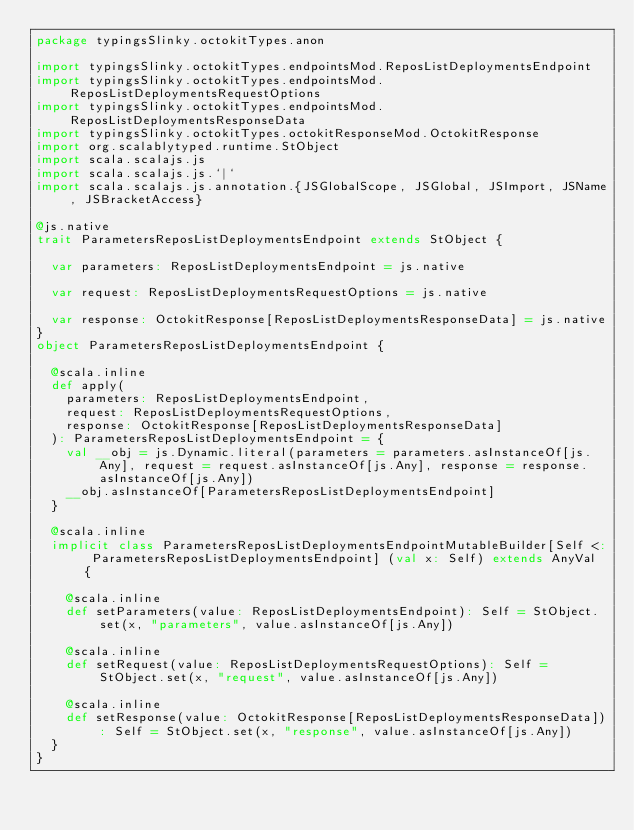Convert code to text. <code><loc_0><loc_0><loc_500><loc_500><_Scala_>package typingsSlinky.octokitTypes.anon

import typingsSlinky.octokitTypes.endpointsMod.ReposListDeploymentsEndpoint
import typingsSlinky.octokitTypes.endpointsMod.ReposListDeploymentsRequestOptions
import typingsSlinky.octokitTypes.endpointsMod.ReposListDeploymentsResponseData
import typingsSlinky.octokitTypes.octokitResponseMod.OctokitResponse
import org.scalablytyped.runtime.StObject
import scala.scalajs.js
import scala.scalajs.js.`|`
import scala.scalajs.js.annotation.{JSGlobalScope, JSGlobal, JSImport, JSName, JSBracketAccess}

@js.native
trait ParametersReposListDeploymentsEndpoint extends StObject {
  
  var parameters: ReposListDeploymentsEndpoint = js.native
  
  var request: ReposListDeploymentsRequestOptions = js.native
  
  var response: OctokitResponse[ReposListDeploymentsResponseData] = js.native
}
object ParametersReposListDeploymentsEndpoint {
  
  @scala.inline
  def apply(
    parameters: ReposListDeploymentsEndpoint,
    request: ReposListDeploymentsRequestOptions,
    response: OctokitResponse[ReposListDeploymentsResponseData]
  ): ParametersReposListDeploymentsEndpoint = {
    val __obj = js.Dynamic.literal(parameters = parameters.asInstanceOf[js.Any], request = request.asInstanceOf[js.Any], response = response.asInstanceOf[js.Any])
    __obj.asInstanceOf[ParametersReposListDeploymentsEndpoint]
  }
  
  @scala.inline
  implicit class ParametersReposListDeploymentsEndpointMutableBuilder[Self <: ParametersReposListDeploymentsEndpoint] (val x: Self) extends AnyVal {
    
    @scala.inline
    def setParameters(value: ReposListDeploymentsEndpoint): Self = StObject.set(x, "parameters", value.asInstanceOf[js.Any])
    
    @scala.inline
    def setRequest(value: ReposListDeploymentsRequestOptions): Self = StObject.set(x, "request", value.asInstanceOf[js.Any])
    
    @scala.inline
    def setResponse(value: OctokitResponse[ReposListDeploymentsResponseData]): Self = StObject.set(x, "response", value.asInstanceOf[js.Any])
  }
}
</code> 